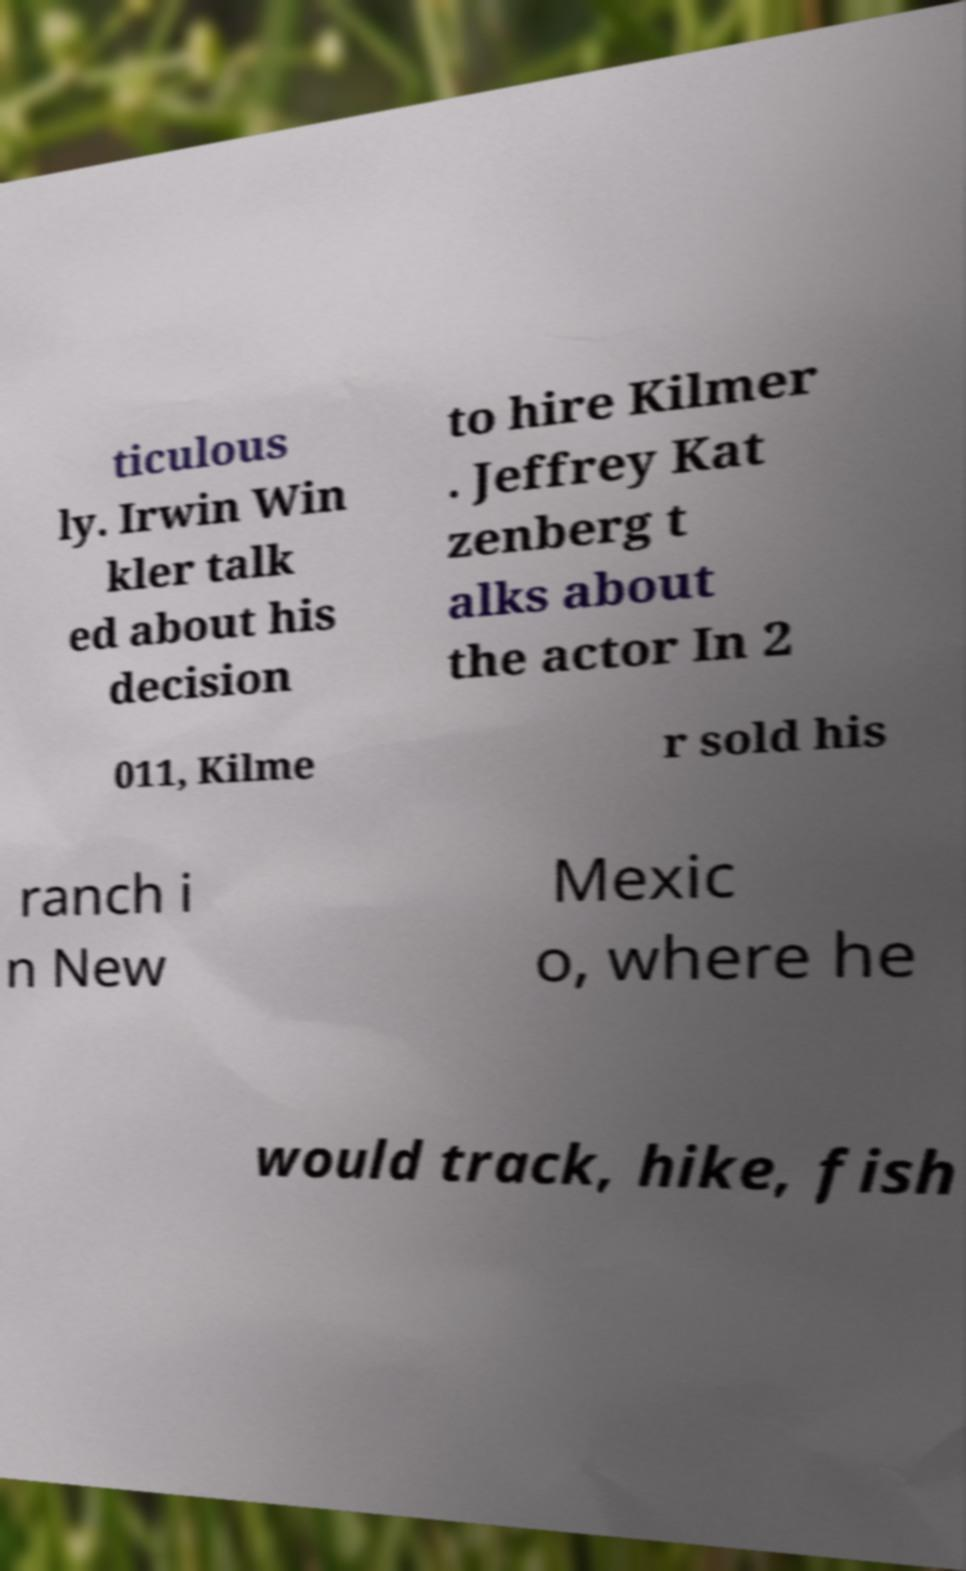For documentation purposes, I need the text within this image transcribed. Could you provide that? ticulous ly. Irwin Win kler talk ed about his decision to hire Kilmer . Jeffrey Kat zenberg t alks about the actor In 2 011, Kilme r sold his ranch i n New Mexic o, where he would track, hike, fish 